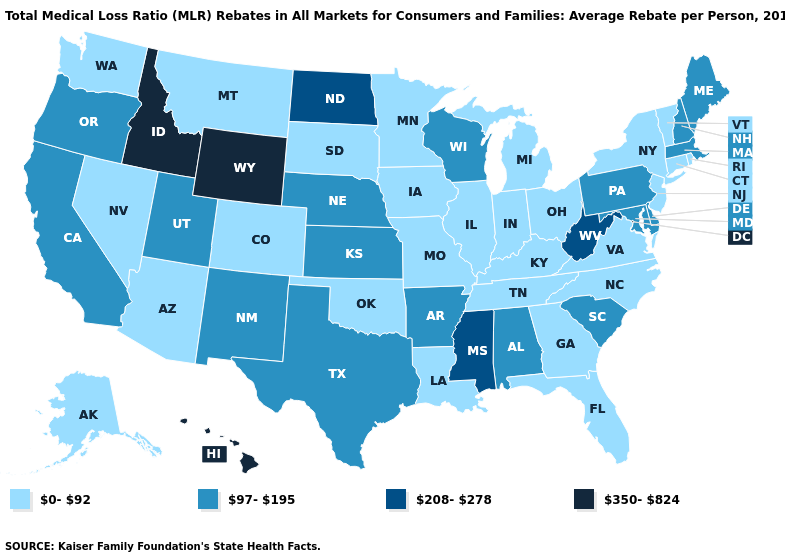Name the states that have a value in the range 350-824?
Give a very brief answer. Hawaii, Idaho, Wyoming. Among the states that border New Hampshire , which have the lowest value?
Be succinct. Vermont. What is the value of Pennsylvania?
Answer briefly. 97-195. What is the value of Arkansas?
Concise answer only. 97-195. What is the value of Delaware?
Keep it brief. 97-195. Name the states that have a value in the range 350-824?
Keep it brief. Hawaii, Idaho, Wyoming. Does Illinois have the lowest value in the USA?
Short answer required. Yes. Which states have the highest value in the USA?
Concise answer only. Hawaii, Idaho, Wyoming. Among the states that border Arizona , which have the lowest value?
Short answer required. Colorado, Nevada. What is the highest value in the USA?
Quick response, please. 350-824. Which states have the lowest value in the Northeast?
Keep it brief. Connecticut, New Jersey, New York, Rhode Island, Vermont. Among the states that border Kansas , does Colorado have the highest value?
Answer briefly. No. Does Louisiana have a higher value than Oklahoma?
Write a very short answer. No. Does Rhode Island have a lower value than Pennsylvania?
Give a very brief answer. Yes. Which states hav the highest value in the West?
Give a very brief answer. Hawaii, Idaho, Wyoming. 